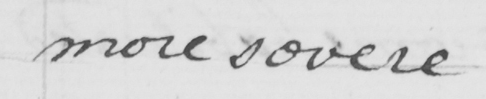What does this handwritten line say? more severe 